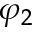<formula> <loc_0><loc_0><loc_500><loc_500>\varphi _ { 2 }</formula> 